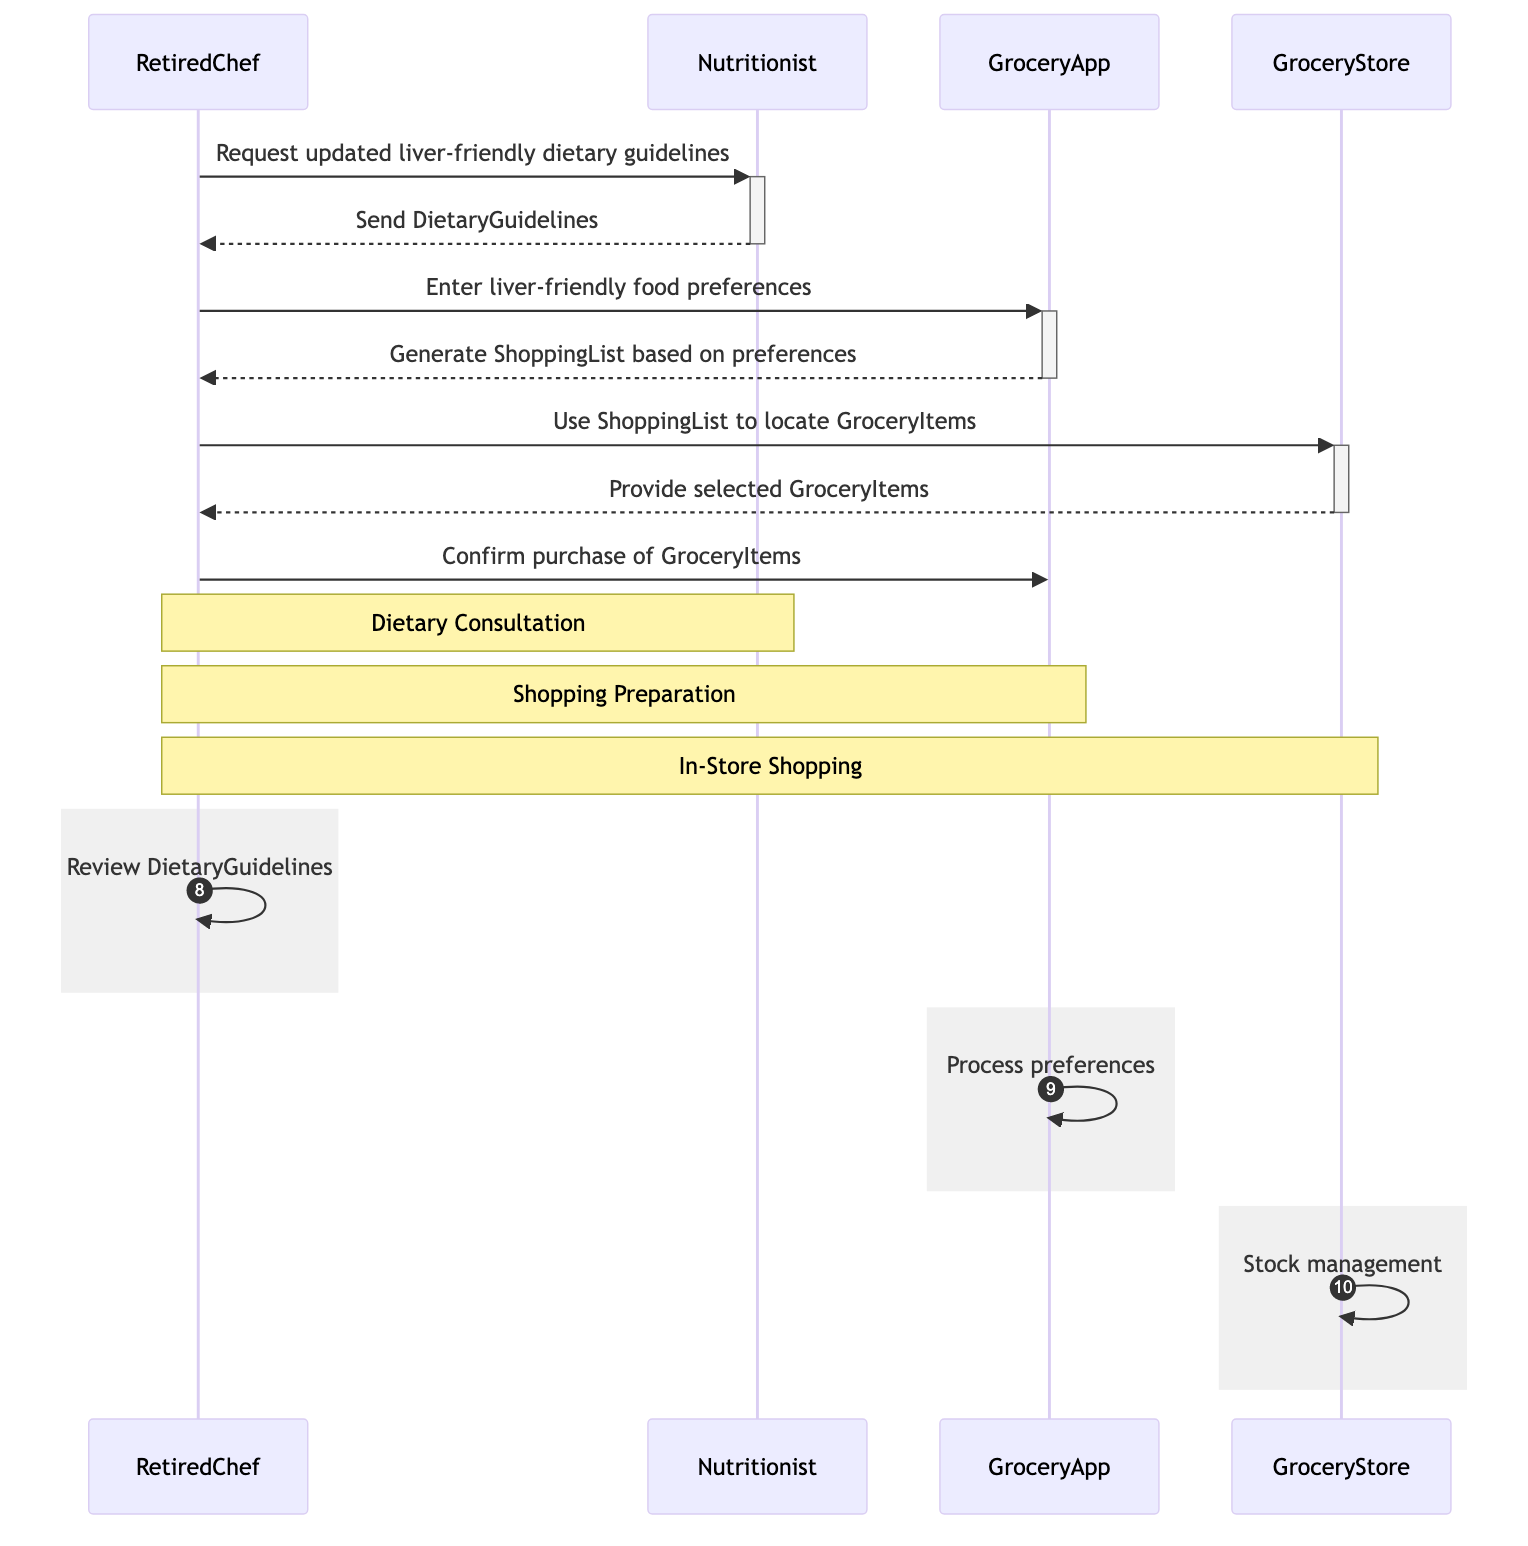What is the first action taken by the RetiredChef? The RetiredChef first requests updated liver-friendly dietary guidelines from the Nutritionist. This is represented by the initial message flow from the RetiredChef to the Nutritionist in the diagram.
Answer: Request updated liver-friendly dietary guidelines How many actors are involved in the sequence diagram? The diagram includes four actors: RetiredChef, Nutritionist, GroceryApp, and GroceryStore. Counting each distinct participant reveals this total.
Answer: Four What document does the Nutritionist send to the RetiredChef? The Nutritionist sends the DietaryGuidelines to the RetiredChef. This is indicated by the message returned to the RetiredChef from the Nutritionist.
Answer: DietaryGuidelines What does the GroceryApp generate based on the RetiredChef's preferences? The GroceryApp generates a ShoppingList based on the RetiredChef's entered liver-friendly food preferences, as indicated in the interaction sequence.
Answer: ShoppingList Which actor confirms the purchase of GroceryItems? The RetiredChef confirms the purchase of the GroceryItems. This is made clear by the last message flow in the sequence directed from the RetiredChef to the GroceryApp.
Answer: RetiredChef What is the action taken by the GroceryStore after the RetiredChef uses the ShoppingList? The GroceryStore provides the selected GroceryItems to the RetiredChef after he uses the ShoppingList. This step is shown in the flow from the GroceryStore to the RetiredChef.
Answer: Provide selected GroceryItems What activity is highlighted under the note section for the Dietary Consultation? The note section for the Dietary Consultation highlights the interaction between the RetiredChef and the Nutritionist, as signified by the area where the note is placed.
Answer: Dietary Consultation How many messages are exchanged between the RetiredChef and the GroceryApp? There are two messages exchanged: one for entering preferences and another for confirming the purchase. This total is counted from the interactions directly involving the GroceryApp.
Answer: Two What internal action does the GroceryApp perform? The GroceryApp processes preferences as indicated in the internal action section derived from the diagram.
Answer: Process preferences 